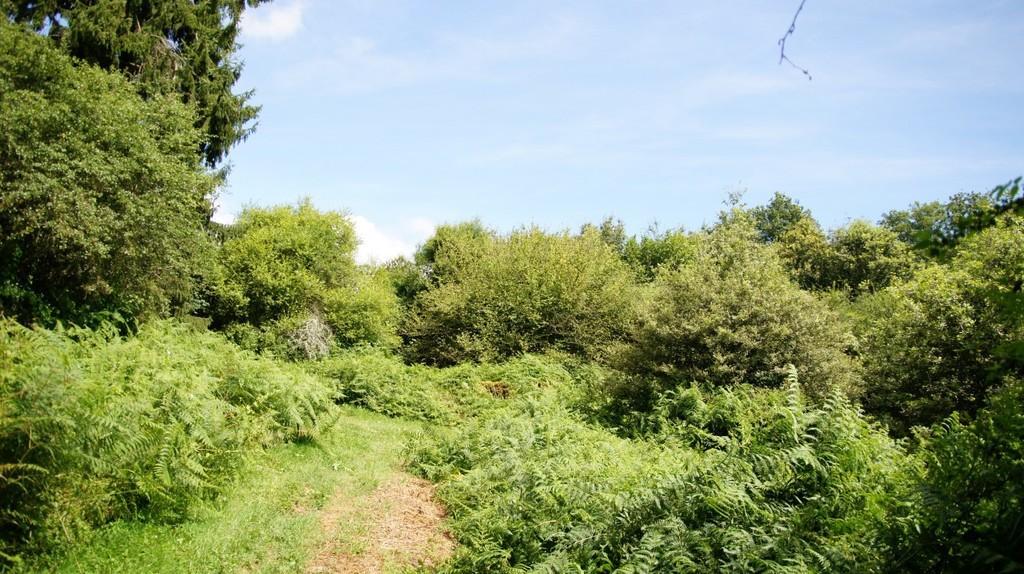Could you give a brief overview of what you see in this image? In this image there are plants, trees and grass on the ground. In the center there is the path. At the top there is the sky. 